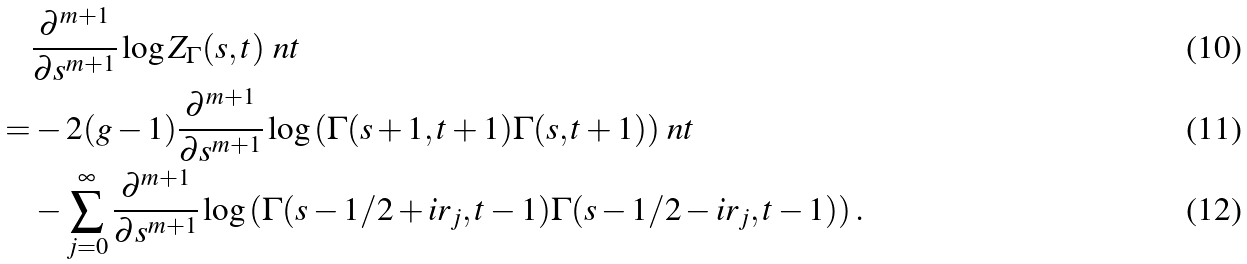<formula> <loc_0><loc_0><loc_500><loc_500>& \frac { \partial ^ { m + 1 } } { \partial s ^ { m + 1 } } \log { Z _ { \Gamma } ( s , t ) } \ n t \\ = & - 2 ( g - 1 ) \frac { \partial ^ { m + 1 } } { \partial s ^ { m + 1 } } \log { \left ( \Gamma ( s + 1 , t + 1 ) \Gamma ( s , t + 1 ) \right ) } \ n t \\ & - \sum _ { j = 0 } ^ { \infty } \frac { \partial ^ { m + 1 } } { \partial s ^ { m + 1 } } \log \left ( \Gamma ( s - 1 / 2 + i r _ { j } , t - 1 ) \Gamma ( s - 1 / 2 - i r _ { j } , t - 1 ) \right ) .</formula> 